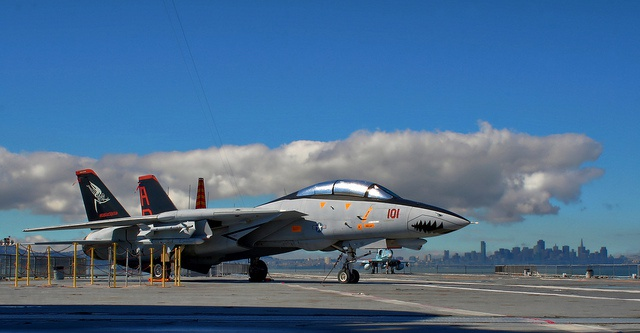Describe the objects in this image and their specific colors. I can see a airplane in blue, black, darkgray, gray, and darkblue tones in this image. 